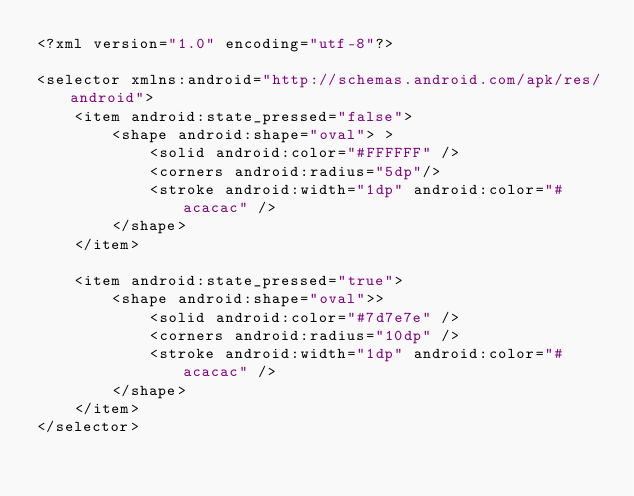<code> <loc_0><loc_0><loc_500><loc_500><_XML_><?xml version="1.0" encoding="utf-8"?>

<selector xmlns:android="http://schemas.android.com/apk/res/android">
    <item android:state_pressed="false">
        <shape android:shape="oval"> >
            <solid android:color="#FFFFFF" />
            <corners android:radius="5dp"/>
            <stroke android:width="1dp" android:color="#acacac" />
        </shape>
    </item>

    <item android:state_pressed="true">
        <shape android:shape="oval">>
            <solid android:color="#7d7e7e" />
            <corners android:radius="10dp" />
            <stroke android:width="1dp" android:color="#acacac" />
        </shape>
    </item>
</selector>
</code> 